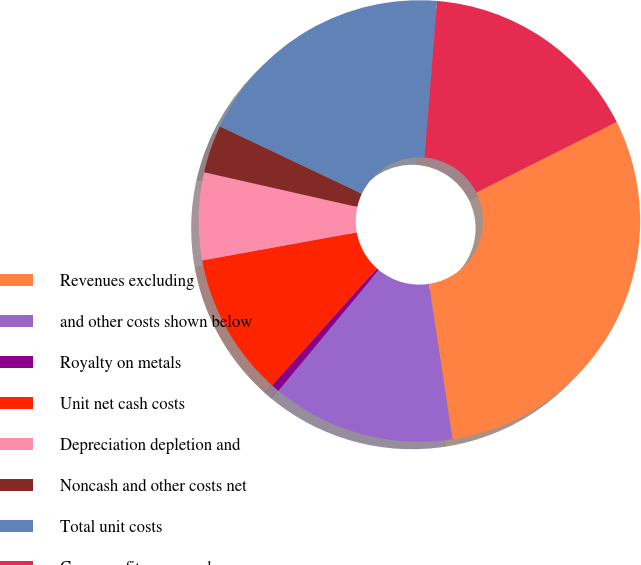Convert chart to OTSL. <chart><loc_0><loc_0><loc_500><loc_500><pie_chart><fcel>Revenues excluding<fcel>and other costs shown below<fcel>Royalty on metals<fcel>Unit net cash costs<fcel>Depreciation depletion and<fcel>Noncash and other costs net<fcel>Total unit costs<fcel>Gross profit per pound<nl><fcel>30.0%<fcel>13.42%<fcel>0.6%<fcel>10.51%<fcel>6.41%<fcel>3.5%<fcel>19.23%<fcel>16.32%<nl></chart> 